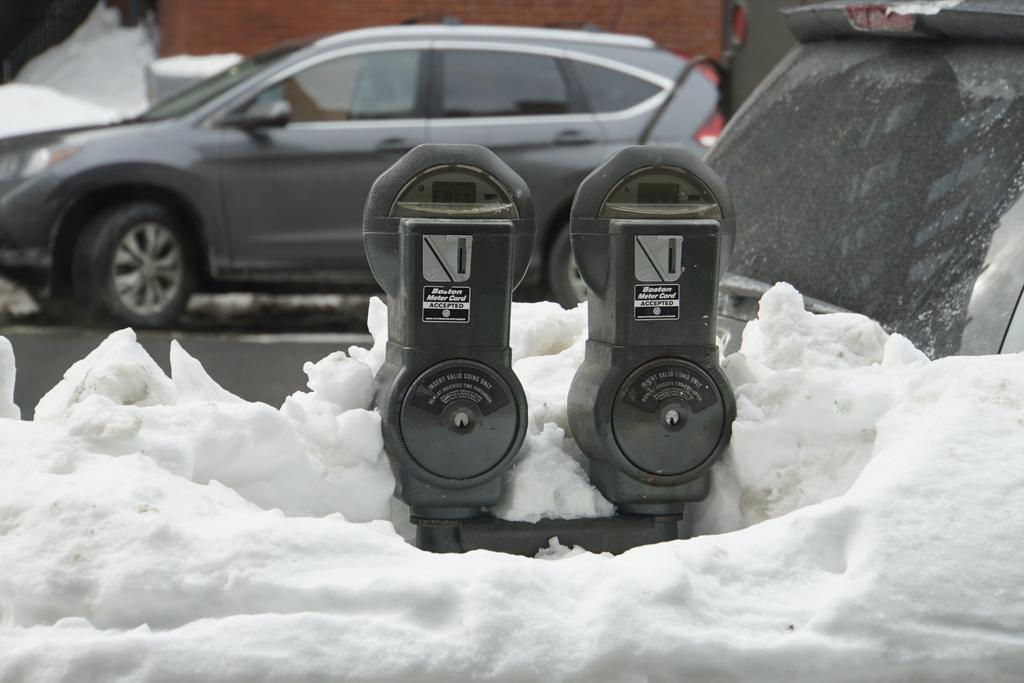<image>
Offer a succinct explanation of the picture presented. Two parking meters that say Boston Meter Card ACCEPTED are buried in snow 